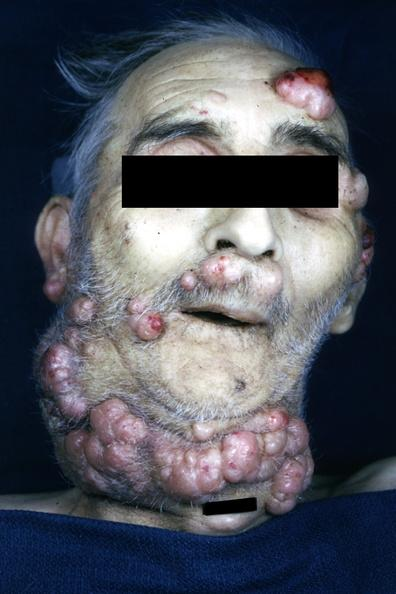how does this image show photo of face and neck?
Answer the question using a single word or phrase. With multiple nodular lesions consisting neoplastic plasma cells iga type 73yo man 